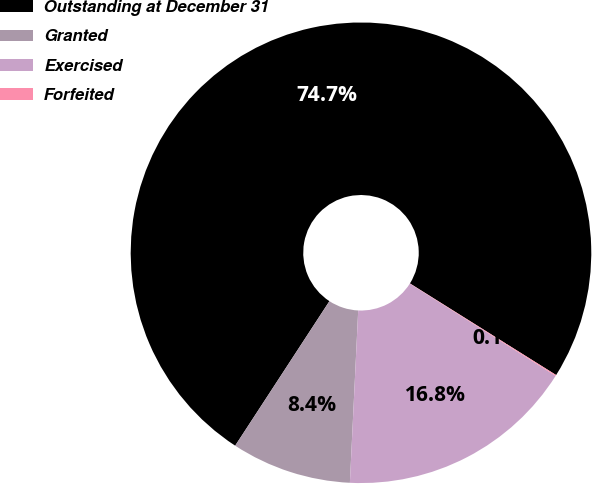<chart> <loc_0><loc_0><loc_500><loc_500><pie_chart><fcel>Outstanding at December 31<fcel>Granted<fcel>Exercised<fcel>Forfeited<nl><fcel>74.71%<fcel>8.43%<fcel>16.79%<fcel>0.07%<nl></chart> 